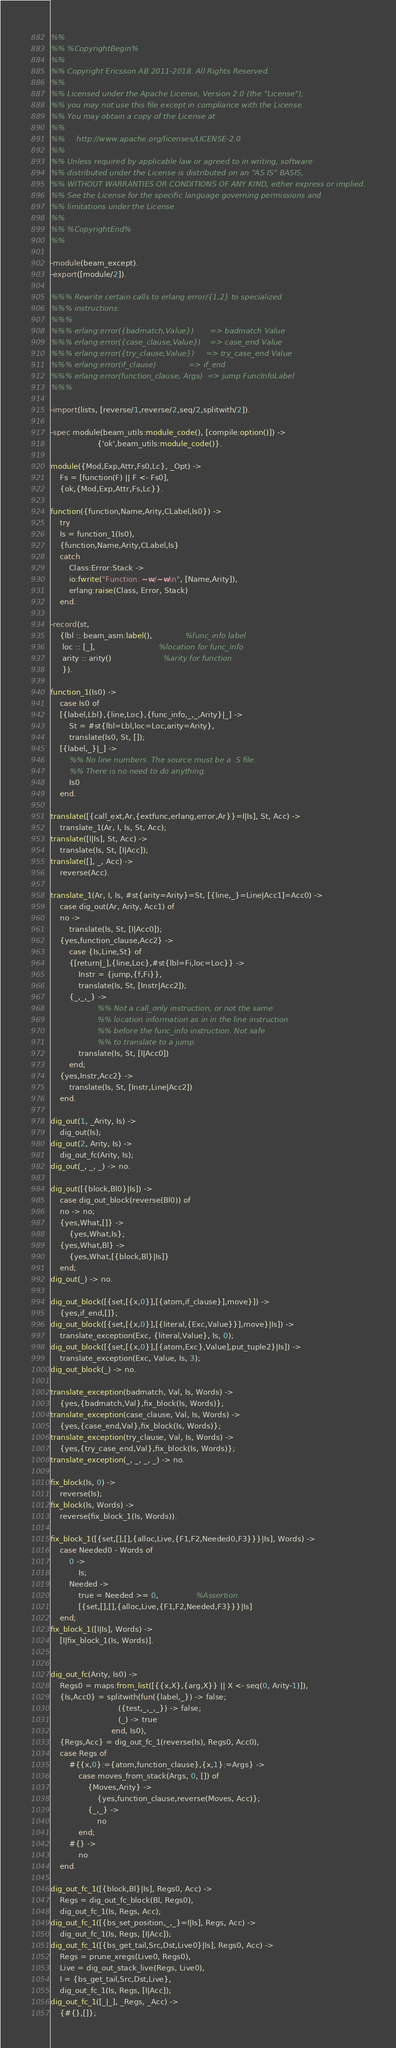<code> <loc_0><loc_0><loc_500><loc_500><_Erlang_>%%
%% %CopyrightBegin%
%%
%% Copyright Ericsson AB 2011-2018. All Rights Reserved.
%%
%% Licensed under the Apache License, Version 2.0 (the "License");
%% you may not use this file except in compliance with the License.
%% You may obtain a copy of the License at
%%
%%     http://www.apache.org/licenses/LICENSE-2.0
%%
%% Unless required by applicable law or agreed to in writing, software
%% distributed under the License is distributed on an "AS IS" BASIS,
%% WITHOUT WARRANTIES OR CONDITIONS OF ANY KIND, either express or implied.
%% See the License for the specific language governing permissions and
%% limitations under the License.
%%
%% %CopyrightEnd%
%%

-module(beam_except).
-export([module/2]).

%%% Rewrite certain calls to erlang:error/{1,2} to specialized
%%% instructions:
%%%
%%% erlang:error({badmatch,Value})       => badmatch Value
%%% erlang:error({case_clause,Value})    => case_end Value
%%% erlang:error({try_clause,Value})     => try_case_end Value
%%% erlang:error(if_clause)              => if_end
%%% erlang:error(function_clause, Args)  => jump FuncInfoLabel
%%%

-import(lists, [reverse/1,reverse/2,seq/2,splitwith/2]).

-spec module(beam_utils:module_code(), [compile:option()]) ->
                    {'ok',beam_utils:module_code()}.

module({Mod,Exp,Attr,Fs0,Lc}, _Opt) ->
    Fs = [function(F) || F <- Fs0],
    {ok,{Mod,Exp,Attr,Fs,Lc}}.

function({function,Name,Arity,CLabel,Is0}) ->
    try
	Is = function_1(Is0),
	{function,Name,Arity,CLabel,Is}
    catch
        Class:Error:Stack ->
	    io:fwrite("Function: ~w/~w\n", [Name,Arity]),
	    erlang:raise(Class, Error, Stack)
    end.

-record(st,
	{lbl :: beam_asm:label(),              %func_info label
	 loc :: [_],                           %location for func_info
	 arity :: arity()                      %arity for function
	 }).

function_1(Is0) ->
    case Is0 of
	[{label,Lbl},{line,Loc},{func_info,_,_,Arity}|_] ->
	    St = #st{lbl=Lbl,loc=Loc,arity=Arity},
	    translate(Is0, St, []);
	[{label,_}|_] ->
	    %% No line numbers. The source must be a .S file.
	    %% There is no need to do anything.
	    Is0
    end.

translate([{call_ext,Ar,{extfunc,erlang,error,Ar}}=I|Is], St, Acc) ->
    translate_1(Ar, I, Is, St, Acc);
translate([I|Is], St, Acc) ->
    translate(Is, St, [I|Acc]);
translate([], _, Acc) ->
    reverse(Acc).

translate_1(Ar, I, Is, #st{arity=Arity}=St, [{line,_}=Line|Acc1]=Acc0) ->
    case dig_out(Ar, Arity, Acc1) of
	no ->
	    translate(Is, St, [I|Acc0]);
	{yes,function_clause,Acc2} ->
	    case {Is,Line,St} of
		{[return|_],{line,Loc},#st{lbl=Fi,loc=Loc}} ->
		    Instr = {jump,{f,Fi}},
		    translate(Is, St, [Instr|Acc2]);
		{_,_,_} ->
                    %% Not a call_only instruction, or not the same
                    %% location information as in in the line instruction
                    %% before the func_info instruction. Not safe
                    %% to translate to a jump.
		    translate(Is, St, [I|Acc0])
	    end;
	{yes,Instr,Acc2} ->
	    translate(Is, St, [Instr,Line|Acc2])
    end.

dig_out(1, _Arity, Is) ->
    dig_out(Is);
dig_out(2, Arity, Is) ->
    dig_out_fc(Arity, Is);
dig_out(_, _, _) -> no.

dig_out([{block,Bl0}|Is]) ->
    case dig_out_block(reverse(Bl0)) of
	no -> no;
	{yes,What,[]} ->
	    {yes,What,Is};
	{yes,What,Bl} ->
	    {yes,What,[{block,Bl}|Is]}
    end;
dig_out(_) -> no.

dig_out_block([{set,[{x,0}],[{atom,if_clause}],move}]) ->
    {yes,if_end,[]};
dig_out_block([{set,[{x,0}],[{literal,{Exc,Value}}],move}|Is]) ->
    translate_exception(Exc, {literal,Value}, Is, 0);
dig_out_block([{set,[{x,0}],[{atom,Exc},Value],put_tuple2}|Is]) ->
    translate_exception(Exc, Value, Is, 3);
dig_out_block(_) -> no.

translate_exception(badmatch, Val, Is, Words) ->
    {yes,{badmatch,Val},fix_block(Is, Words)};
translate_exception(case_clause, Val, Is, Words) ->
    {yes,{case_end,Val},fix_block(Is, Words)};
translate_exception(try_clause, Val, Is, Words) ->
    {yes,{try_case_end,Val},fix_block(Is, Words)};
translate_exception(_, _, _, _) -> no.

fix_block(Is, 0) ->
    reverse(Is);
fix_block(Is, Words) ->
    reverse(fix_block_1(Is, Words)).

fix_block_1([{set,[],[],{alloc,Live,{F1,F2,Needed0,F3}}}|Is], Words) ->
    case Needed0 - Words of
        0 ->
            Is;
        Needed ->
            true = Needed >= 0,				%Assertion.
            [{set,[],[],{alloc,Live,{F1,F2,Needed,F3}}}|Is]
    end;
fix_block_1([I|Is], Words) ->
    [I|fix_block_1(Is, Words)].


dig_out_fc(Arity, Is0) ->
    Regs0 = maps:from_list([{{x,X},{arg,X}} || X <- seq(0, Arity-1)]),
    {Is,Acc0} = splitwith(fun({label,_}) -> false;
                             ({test,_,_,_}) -> false;
                             (_) -> true
                          end, Is0),
    {Regs,Acc} = dig_out_fc_1(reverse(Is), Regs0, Acc0),
    case Regs of
        #{{x,0}:={atom,function_clause},{x,1}:=Args} ->
            case moves_from_stack(Args, 0, []) of
                {Moves,Arity} ->
                    {yes,function_clause,reverse(Moves, Acc)};
                {_,_} ->
                    no
            end;
        #{} ->
            no
    end.

dig_out_fc_1([{block,Bl}|Is], Regs0, Acc) ->
    Regs = dig_out_fc_block(Bl, Regs0),
    dig_out_fc_1(Is, Regs, Acc);
dig_out_fc_1([{bs_set_position,_,_}=I|Is], Regs, Acc) ->
    dig_out_fc_1(Is, Regs, [I|Acc]);
dig_out_fc_1([{bs_get_tail,Src,Dst,Live0}|Is], Regs0, Acc) ->
    Regs = prune_xregs(Live0, Regs0),
    Live = dig_out_stack_live(Regs, Live0),
    I = {bs_get_tail,Src,Dst,Live},
    dig_out_fc_1(Is, Regs, [I|Acc]);
dig_out_fc_1([_|_], _Regs, _Acc) ->
    {#{},[]};</code> 